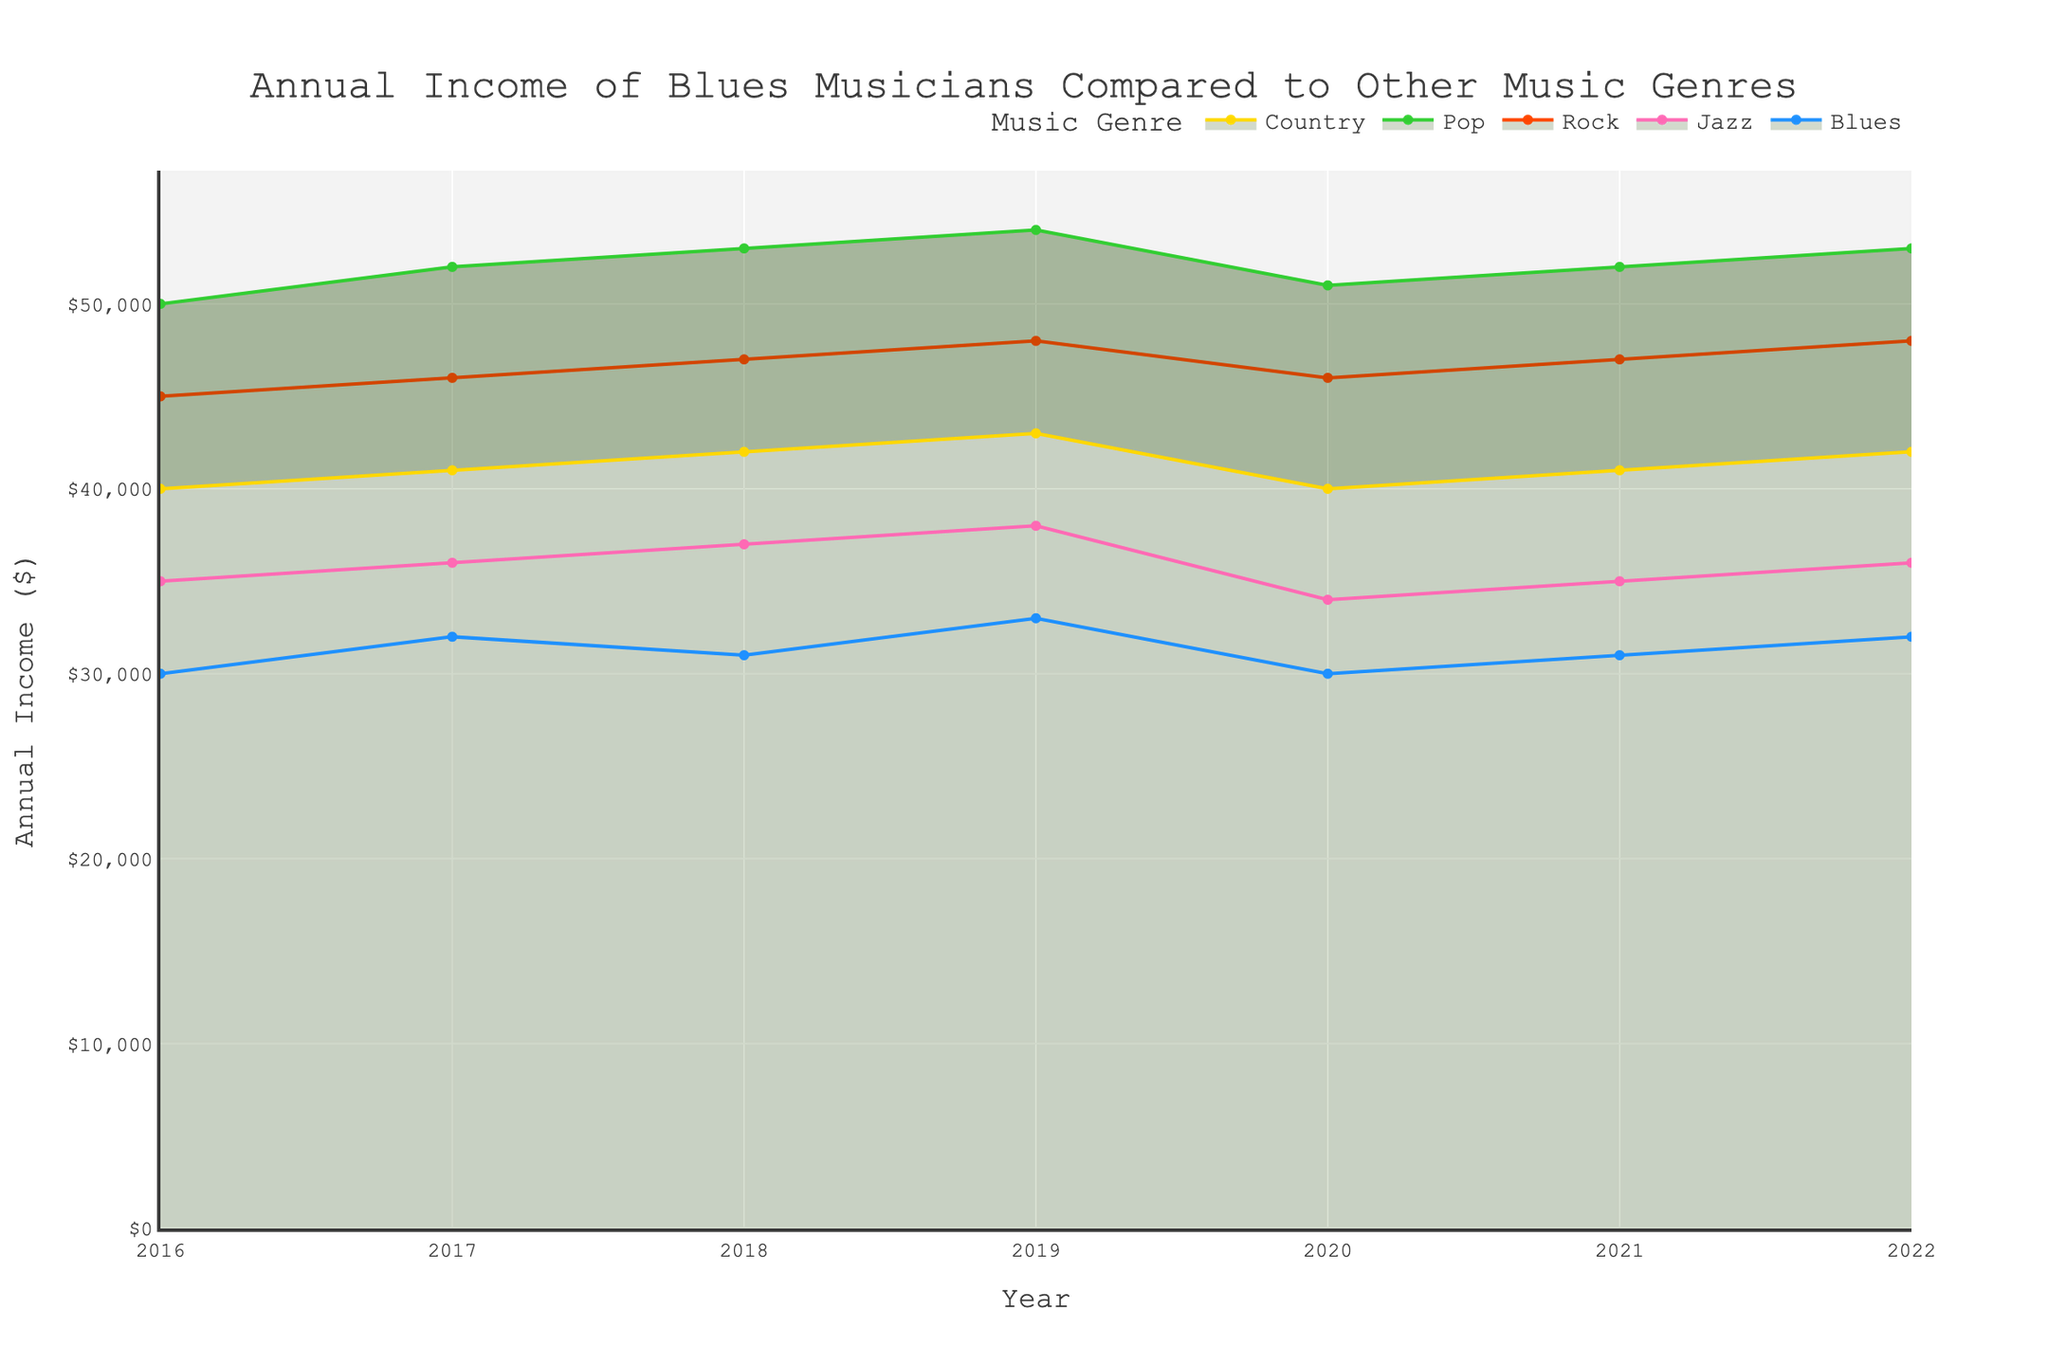What is the title of the chart? The title can be found at the top of the area chart, which provides a summary of what the chart is showing.
Answer: Annual Income of Blues Musicians Compared to Other Music Genres What does the x-axis represent? The x-axis represents the years, which is the time period over which the income data is spread and shown.
Answer: Year What is the income for Blues musicians in 2020? Locate the year 2020 on the x-axis and follow the corresponding value for Blues on the y-axis.
Answer: $30,000 Which genre had the highest annual income in 2019? Compare the heights of all genre areas for the year 2019 on the x-axis. The highest area corresponds to the highest income.
Answer: Pop How did the annual income for Blues musicians change from 2016 to 2017? Check the values for Blues in 2016 and 2017 and compute the difference.
Answer: Increased by $2,000 Which genre experienced the most significant drop in annual income in 2020? Compare the size of the drop for each genre between 2019 and 2020.
Answer: Pop Over the entire period, which genre had the most stable annual income (least fluctuation)? Observe the smoothest and least varying area across the years.
Answer: Country What was the average income for Jazz musicians from 2016 to 2022? Sum the annual income values for Jazz from 2016 to 2022 and divide by the number of years (7). Calculation: (35000+36000+37000+38000+34000+35000+36000)/7 = 35857
Answer: $35,857 In which year did Blues musicians experience the highest income? Look for the peak value in the Blues area over the years.
Answer: 2022 Compare the growth rates of Blues and Rock incomes from 2016 to 2022. Compute the percentage increase over the period for both genres. Calculation for Blues: ((32000-30000)/30000)*100 = 6.67%; Calculation for Rock: ((48000-45000)/45000)*100 = 6.67%
Answer: They have the same growth rate of 6.67% 